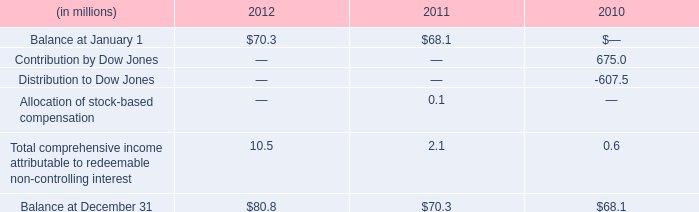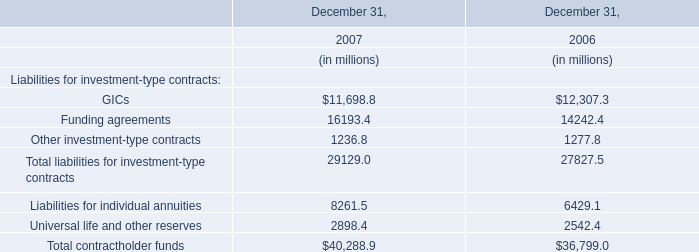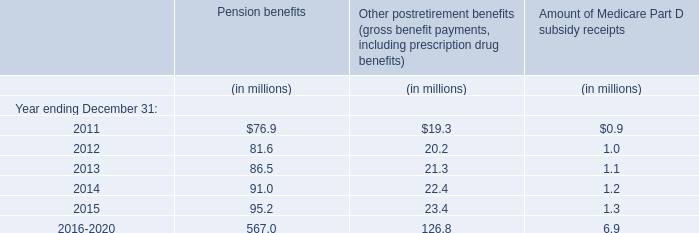in 2012 what was the ratio of the eligibility limits for farmer and cooperative to individual participants in the family farmer and rancher protection fund 
Computations: (100000 / 25000)
Answer: 4.0. 